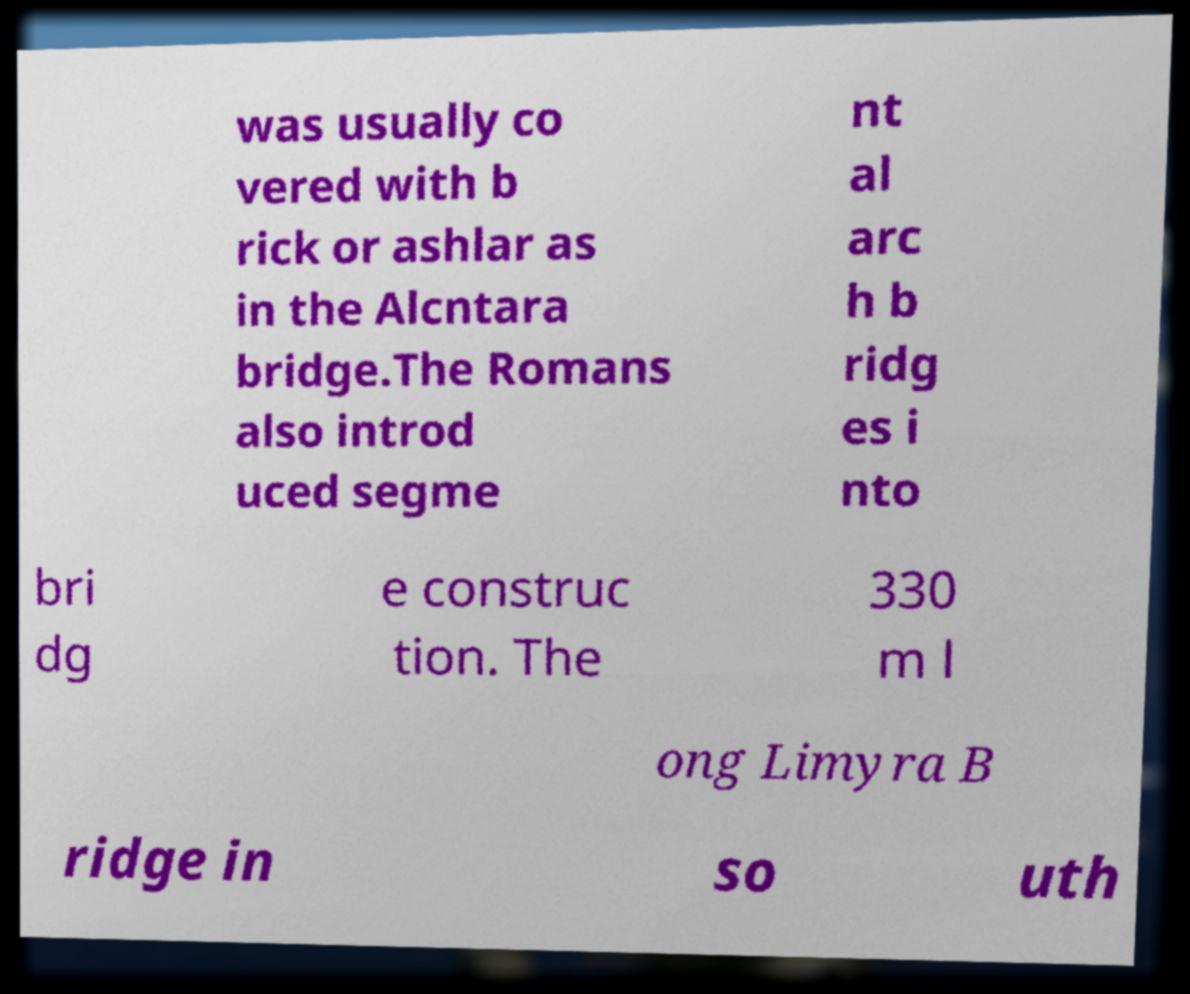There's text embedded in this image that I need extracted. Can you transcribe it verbatim? was usually co vered with b rick or ashlar as in the Alcntara bridge.The Romans also introd uced segme nt al arc h b ridg es i nto bri dg e construc tion. The 330 m l ong Limyra B ridge in so uth 